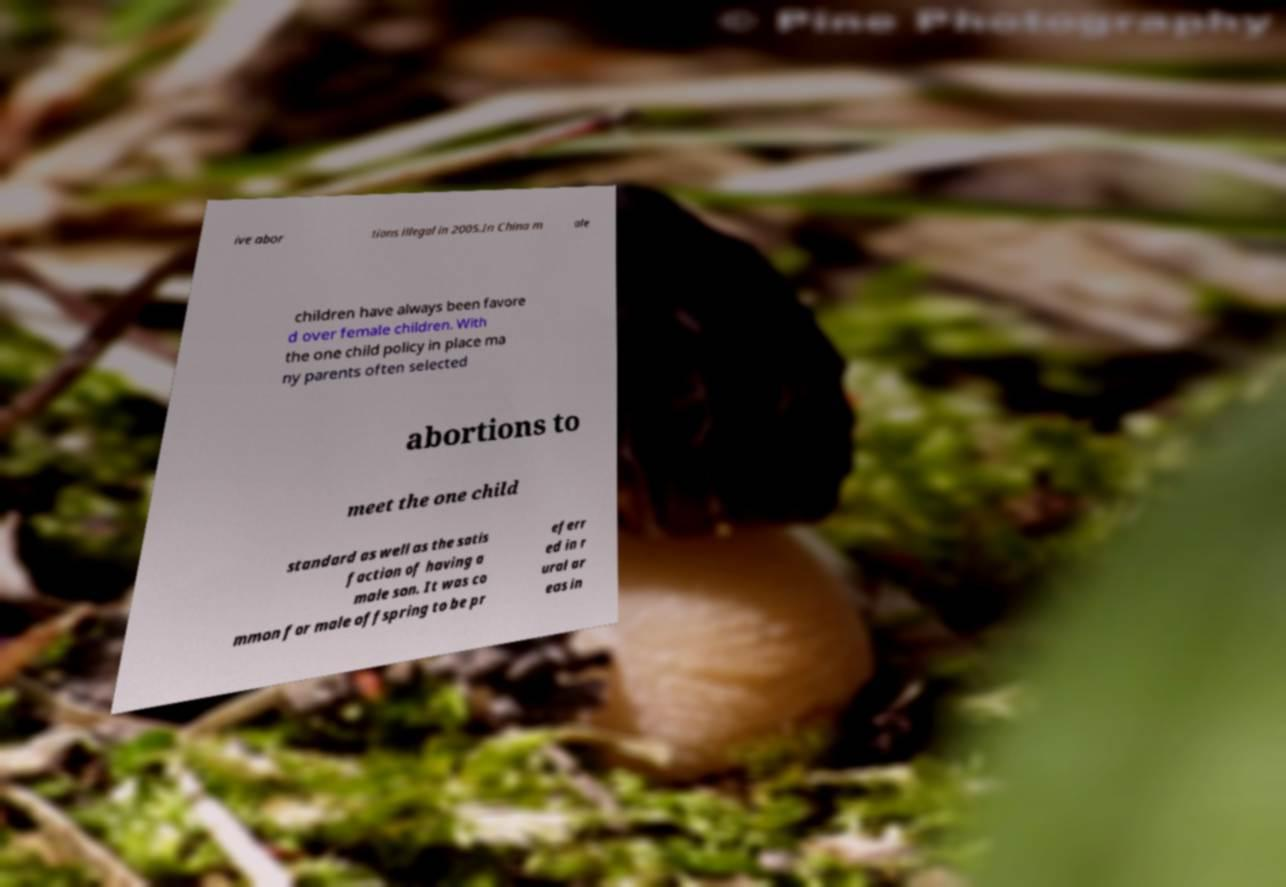I need the written content from this picture converted into text. Can you do that? ive abor tions illegal in 2005.In China m ale children have always been favore d over female children. With the one child policy in place ma ny parents often selected abortions to meet the one child standard as well as the satis faction of having a male son. It was co mmon for male offspring to be pr eferr ed in r ural ar eas in 